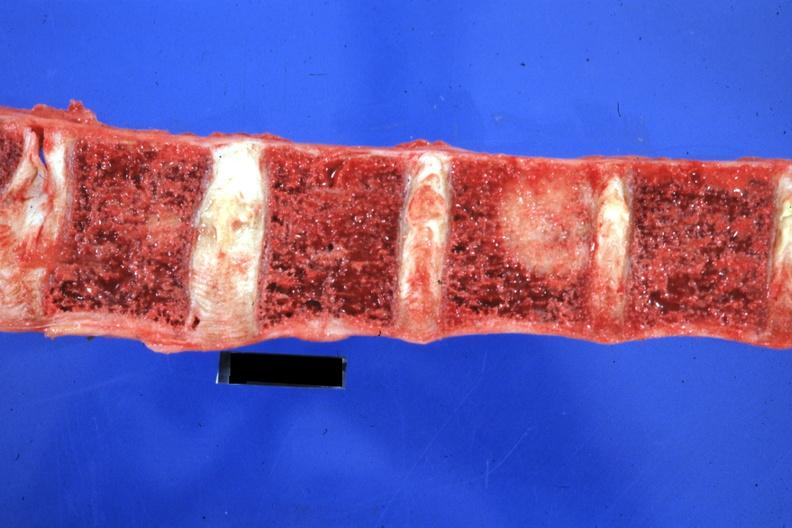s joints present?
Answer the question using a single word or phrase. Yes 